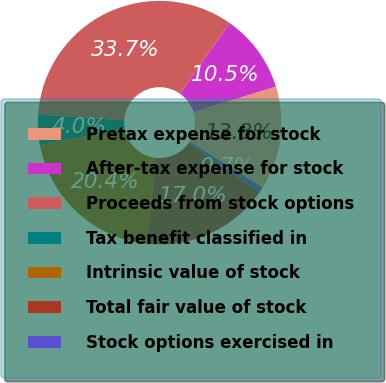Convert chart to OTSL. <chart><loc_0><loc_0><loc_500><loc_500><pie_chart><fcel>Pretax expense for stock<fcel>After-tax expense for stock<fcel>Proceeds from stock options<fcel>Tax benefit classified in<fcel>Intrinsic value of stock<fcel>Total fair value of stock<fcel>Stock options exercised in<nl><fcel>13.75%<fcel>10.46%<fcel>33.69%<fcel>4.0%<fcel>20.35%<fcel>17.05%<fcel>0.7%<nl></chart> 